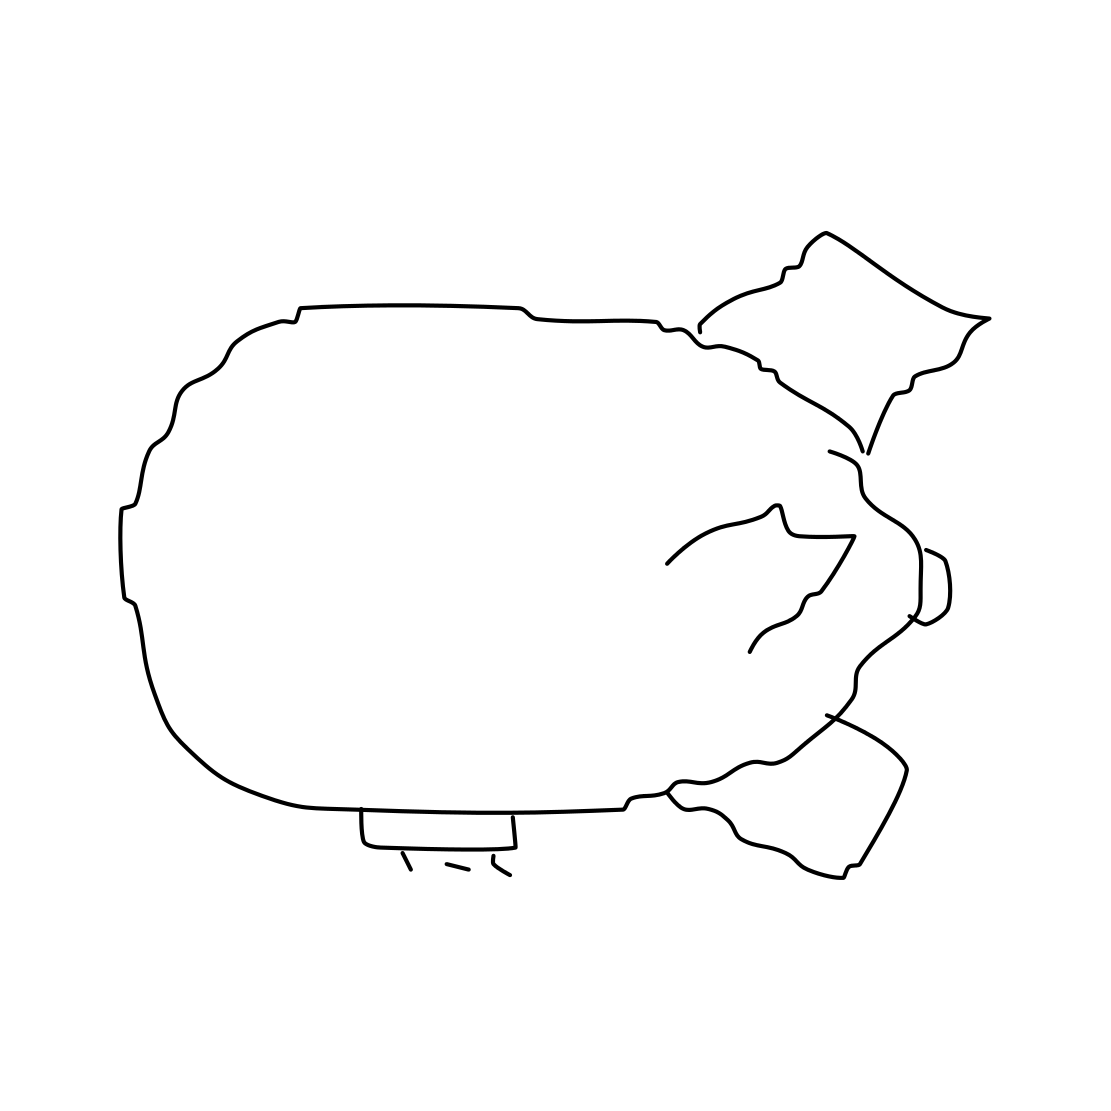What are the distinctive features of this blimp? The blimp shown in the line drawing is characterized by its large, elongated balloon body, which is essential for buoyancy. It also features a gondola or a cabin beneath, where the pilot and passengers can be accommodated, and tail fins that provide stability and steerage. 